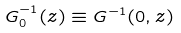Convert formula to latex. <formula><loc_0><loc_0><loc_500><loc_500>G ^ { - 1 } _ { 0 } ( z ) \equiv G ^ { - 1 } ( 0 , z )</formula> 